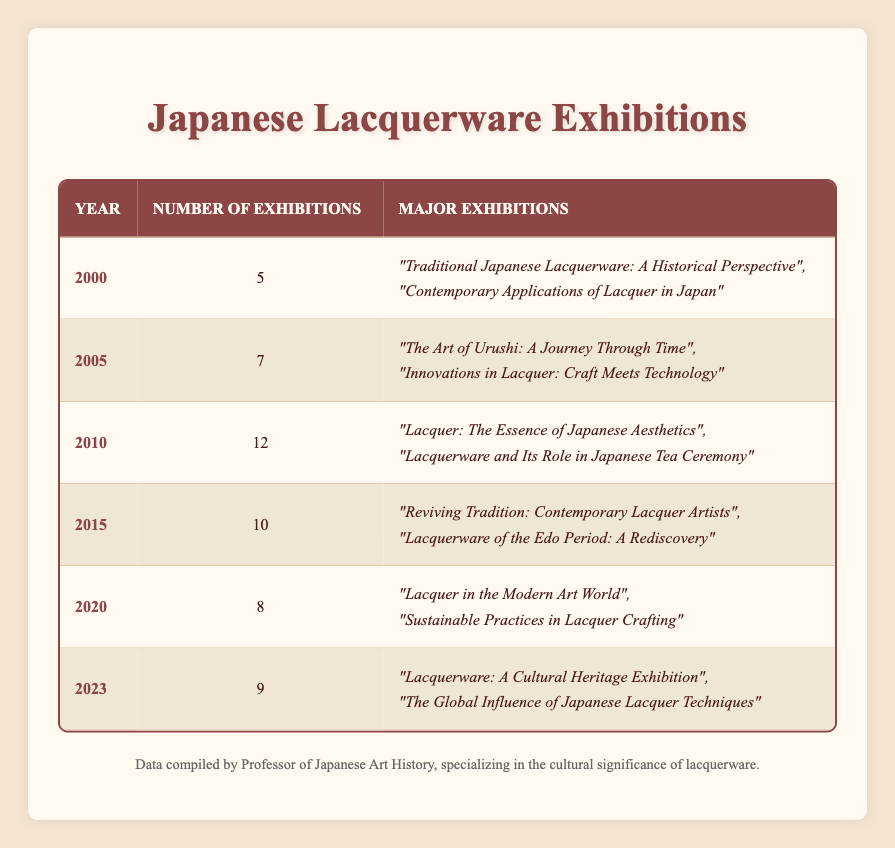What was the highest number of exhibitions held in a single year? Upon reviewing the table, the year with the highest number of exhibitions is 2010, where there were 12 exhibitions.
Answer: 12 What are the names of the major exhibitions held in 2023? The table indicates that two major exhibitions in 2023 were: "Lacquerware: A Cultural Heritage Exhibition" and "The Global Influence of Japanese Lacquer Techniques."
Answer: "Lacquerware: A Cultural Heritage Exhibition", "The Global Influence of Japanese Lacquer Techniques" How many exhibitions were held between the years 2000 and 2010? By summing the number of exhibitions for the years 2000 (5), 2005 (7), and 2010 (12), we get 5 + 7 + 12 = 24.
Answer: 24 Was there an increase in the number of exhibitions from 2005 to 2010? Yes, comparing the two years: 2005 had 7 exhibitions and 2010 had 12 exhibitions, showing an increase of 12 - 7 = 5.
Answer: Yes What is the average number of exhibitions held from 2000 to 2023? The total number of exhibitions from 2000 (5) + 2005 (7) + 2010 (12) + 2015 (10) + 2020 (8) + 2023 (9) equals 51. This is divided by 6 years, yielding an average of 51 / 6 = 8.5.
Answer: 8.5 In which year were the fewest exhibitions held? Looking through the table, the year with the fewest exhibitions is 2000 with 5 exhibitions.
Answer: 2000 How many years had more than 10 exhibitions? By examining the data, only the year 2010 had more than 10 exhibitions, which is 12. Hence, there is only one year in this category.
Answer: 1 What was the difference in the number of exhibitions between 2020 and 2023? The number of exhibitions in 2023 was 9, while in 2020 it was 8. The difference is calculated as 9 - 8 = 1.
Answer: 1 Did the number of exhibitions decrease from 2010 to 2015? Yes, in 2010, there were 12 exhibitions, while in 2015, there were 10 exhibitions. This shows a decrease of 12 - 10 = 2.
Answer: Yes 